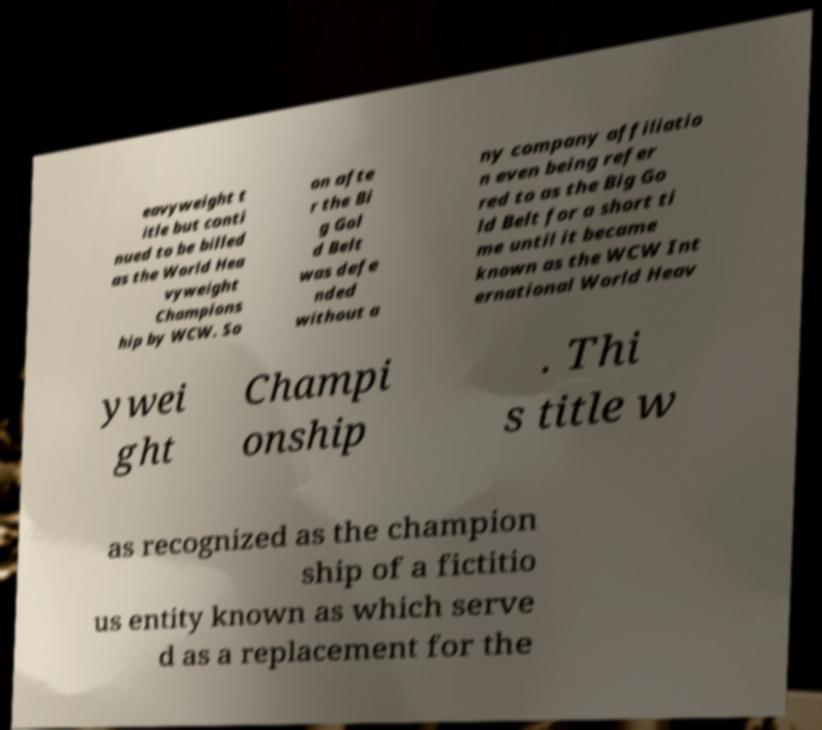Can you read and provide the text displayed in the image?This photo seems to have some interesting text. Can you extract and type it out for me? eavyweight t itle but conti nued to be billed as the World Hea vyweight Champions hip by WCW. So on afte r the Bi g Gol d Belt was defe nded without a ny company affiliatio n even being refer red to as the Big Go ld Belt for a short ti me until it became known as the WCW Int ernational World Heav ywei ght Champi onship . Thi s title w as recognized as the champion ship of a fictitio us entity known as which serve d as a replacement for the 